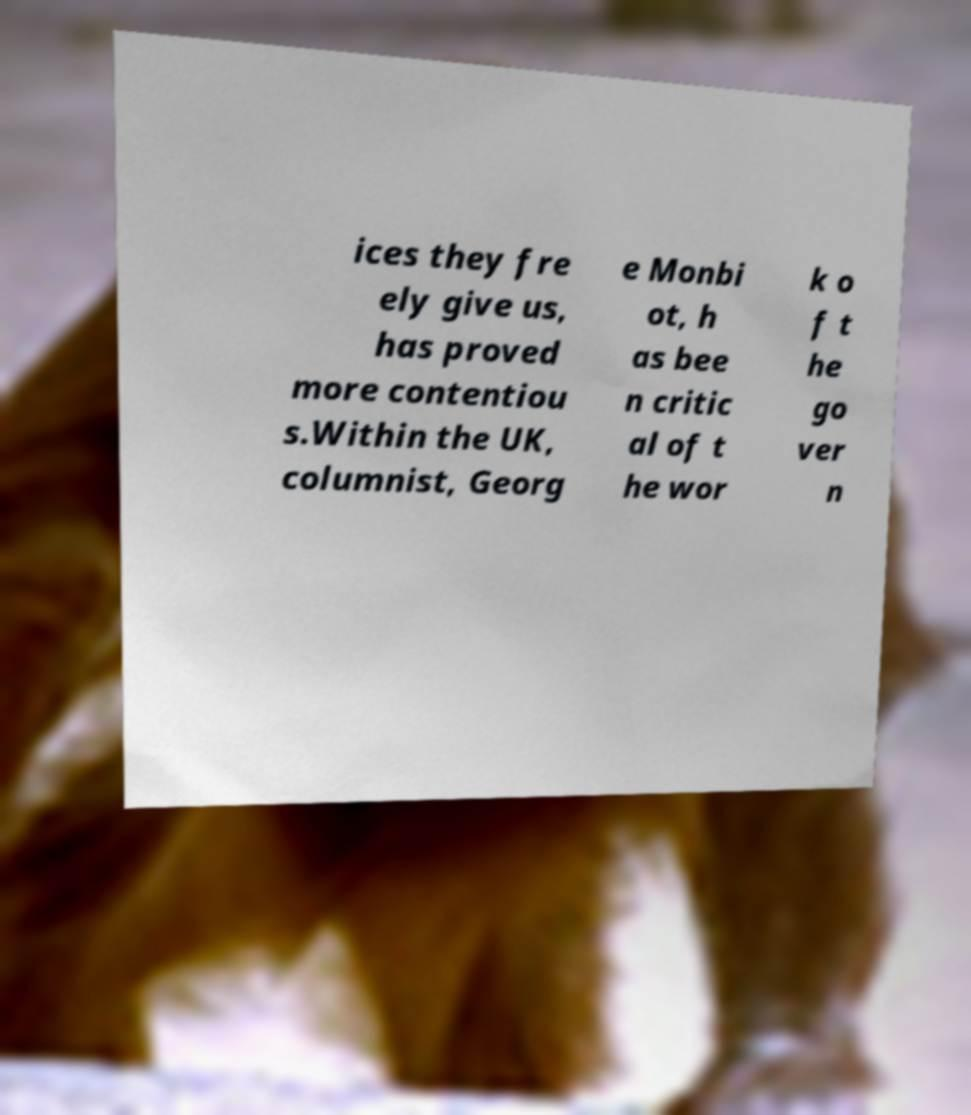For documentation purposes, I need the text within this image transcribed. Could you provide that? ices they fre ely give us, has proved more contentiou s.Within the UK, columnist, Georg e Monbi ot, h as bee n critic al of t he wor k o f t he go ver n 